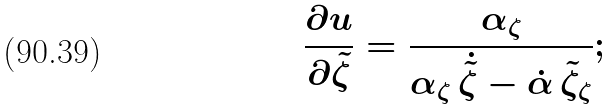Convert formula to latex. <formula><loc_0><loc_0><loc_500><loc_500>\frac { \partial u } { \partial \tilde { \zeta } } = \frac { \alpha _ { \zeta } } { \alpha _ { \zeta } \, \dot { \tilde { \zeta } } - \dot { \alpha } \, \tilde { \zeta } _ { \zeta } } ;</formula> 